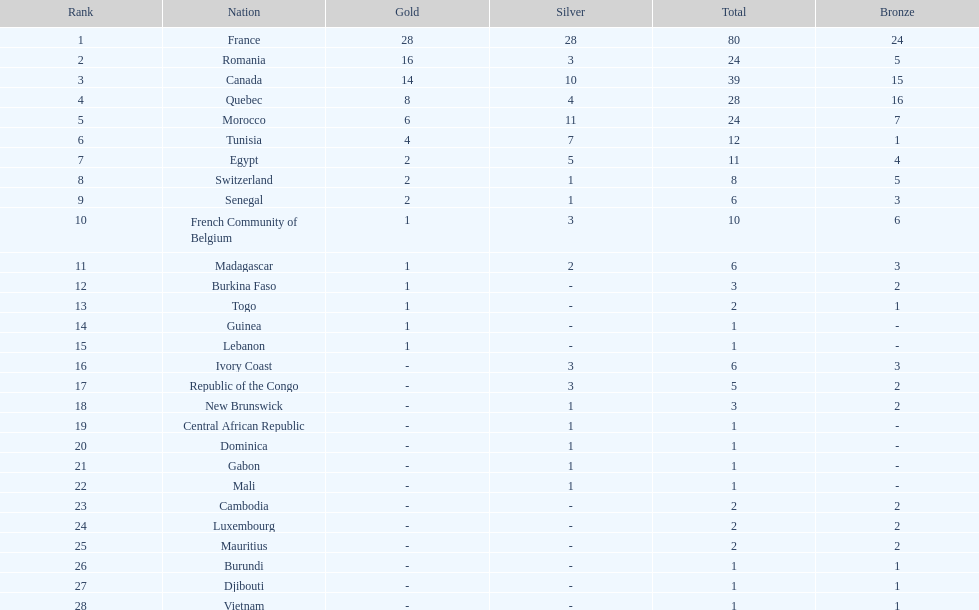How many counties have at least one silver medal? 18. 